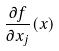<formula> <loc_0><loc_0><loc_500><loc_500>\frac { \partial f } { \partial x _ { j } } ( x )</formula> 